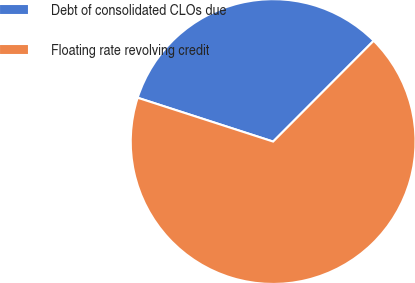Convert chart. <chart><loc_0><loc_0><loc_500><loc_500><pie_chart><fcel>Debt of consolidated CLOs due<fcel>Floating rate revolving credit<nl><fcel>32.5%<fcel>67.5%<nl></chart> 